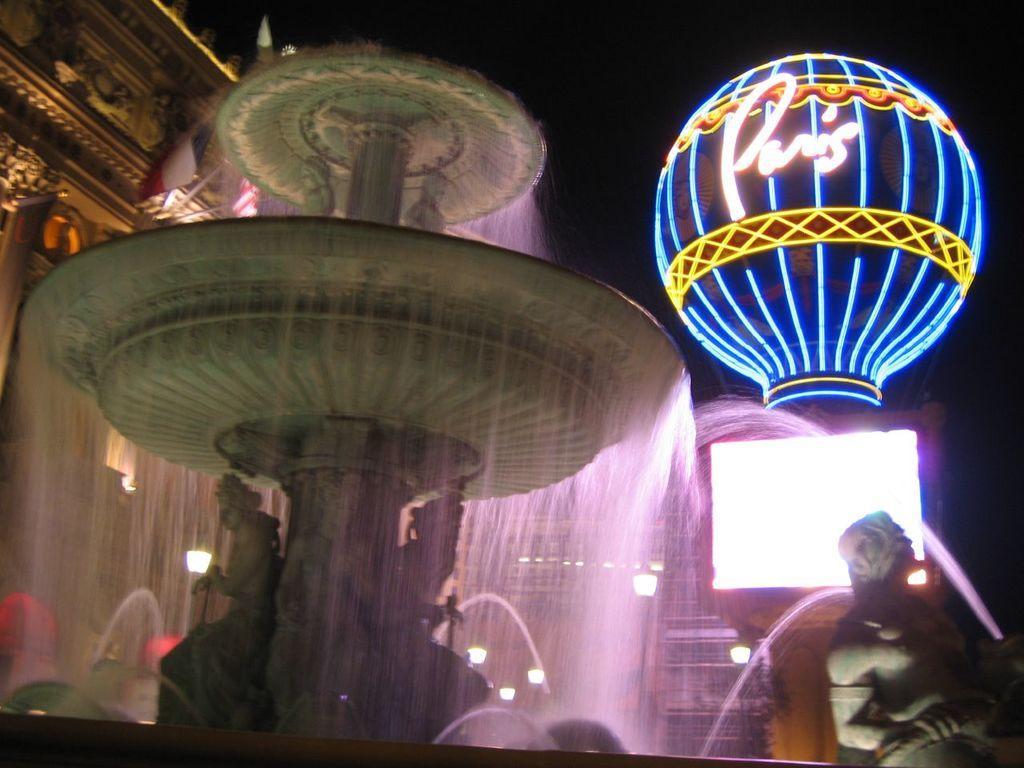Can you describe this image briefly? This picture seems to be clicked outside. On the right corner we can see the sculpture of a person holding some objects. On the left we can see a fountain and the sculptures of some persons and some objects and we can see the waterfall. On the right we can see a dome and we can see the decoration lights. In the background we can see the building, lights and some other objects. 